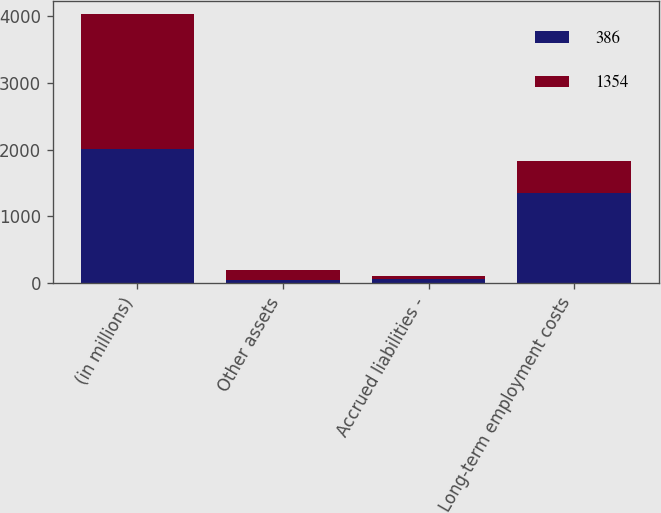<chart> <loc_0><loc_0><loc_500><loc_500><stacked_bar_chart><ecel><fcel>(in millions)<fcel>Other assets<fcel>Accrued liabilities -<fcel>Long-term employment costs<nl><fcel>386<fcel>2014<fcel>42<fcel>55<fcel>1341<nl><fcel>1354<fcel>2013<fcel>151<fcel>55<fcel>482<nl></chart> 